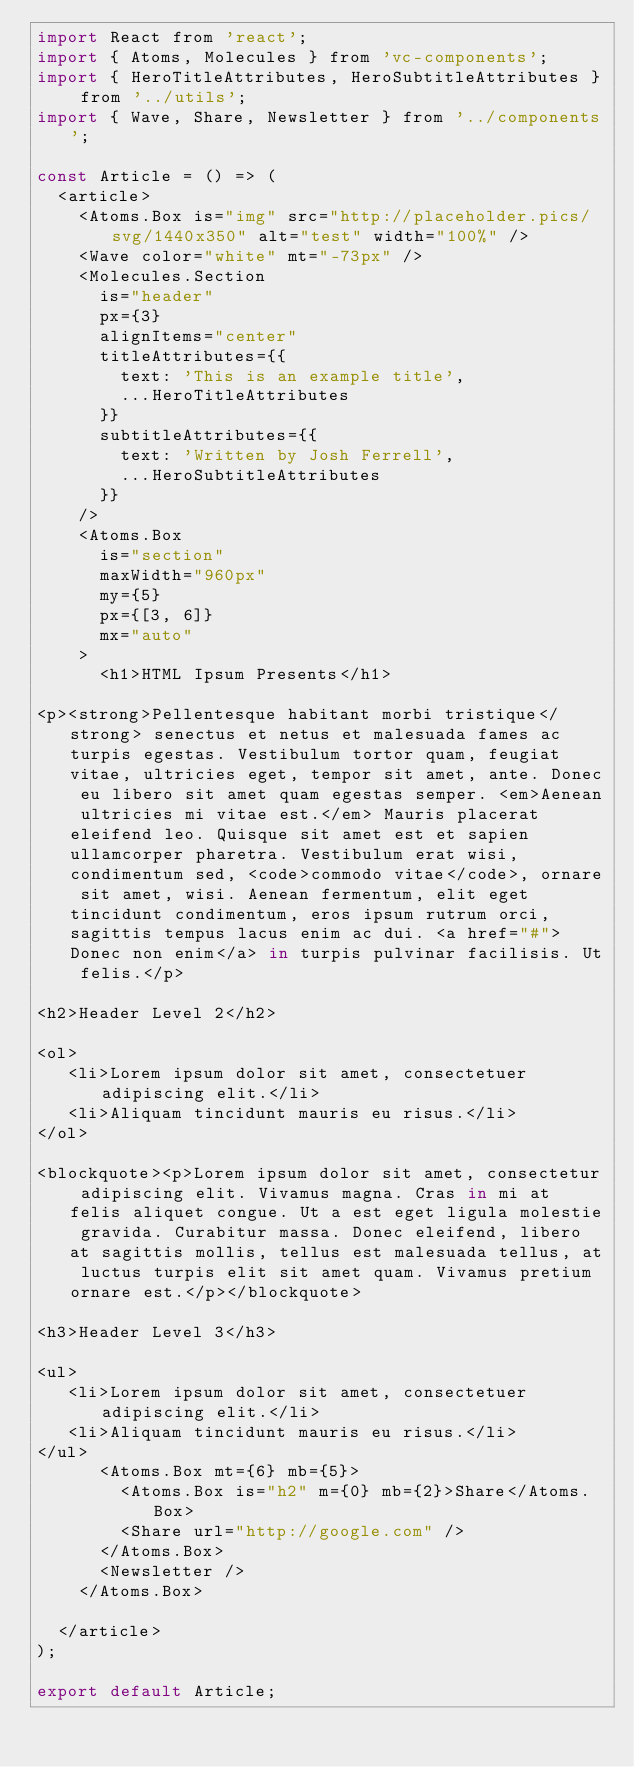Convert code to text. <code><loc_0><loc_0><loc_500><loc_500><_JavaScript_>import React from 'react';
import { Atoms, Molecules } from 'vc-components';
import { HeroTitleAttributes, HeroSubtitleAttributes } from '../utils';
import { Wave, Share, Newsletter } from '../components';

const Article = () => (
	<article>
		<Atoms.Box is="img" src="http://placeholder.pics/svg/1440x350" alt="test" width="100%" />
		<Wave color="white" mt="-73px" />
		<Molecules.Section
			is="header"
			px={3}
			alignItems="center"
			titleAttributes={{
				text: 'This is an example title',
				...HeroTitleAttributes
			}}
			subtitleAttributes={{
				text: 'Written by Josh Ferrell',
				...HeroSubtitleAttributes
			}}
		/>
		<Atoms.Box
			is="section"
			maxWidth="960px"
			my={5}
			px={[3, 6]}
			mx="auto"
		>
			<h1>HTML Ipsum Presents</h1>

<p><strong>Pellentesque habitant morbi tristique</strong> senectus et netus et malesuada fames ac turpis egestas. Vestibulum tortor quam, feugiat vitae, ultricies eget, tempor sit amet, ante. Donec eu libero sit amet quam egestas semper. <em>Aenean ultricies mi vitae est.</em> Mauris placerat eleifend leo. Quisque sit amet est et sapien ullamcorper pharetra. Vestibulum erat wisi, condimentum sed, <code>commodo vitae</code>, ornare sit amet, wisi. Aenean fermentum, elit eget tincidunt condimentum, eros ipsum rutrum orci, sagittis tempus lacus enim ac dui. <a href="#">Donec non enim</a> in turpis pulvinar facilisis. Ut felis.</p>

<h2>Header Level 2</h2>

<ol>
   <li>Lorem ipsum dolor sit amet, consectetuer adipiscing elit.</li>
   <li>Aliquam tincidunt mauris eu risus.</li>
</ol>

<blockquote><p>Lorem ipsum dolor sit amet, consectetur adipiscing elit. Vivamus magna. Cras in mi at felis aliquet congue. Ut a est eget ligula molestie gravida. Curabitur massa. Donec eleifend, libero at sagittis mollis, tellus est malesuada tellus, at luctus turpis elit sit amet quam. Vivamus pretium ornare est.</p></blockquote>

<h3>Header Level 3</h3>

<ul>
   <li>Lorem ipsum dolor sit amet, consectetuer adipiscing elit.</li>
   <li>Aliquam tincidunt mauris eu risus.</li>
</ul>
			<Atoms.Box mt={6} mb={5}>
				<Atoms.Box is="h2" m={0} mb={2}>Share</Atoms.Box>
				<Share url="http://google.com" />
			</Atoms.Box>
			<Newsletter />
		</Atoms.Box>

	</article>
);

export default Article;
</code> 